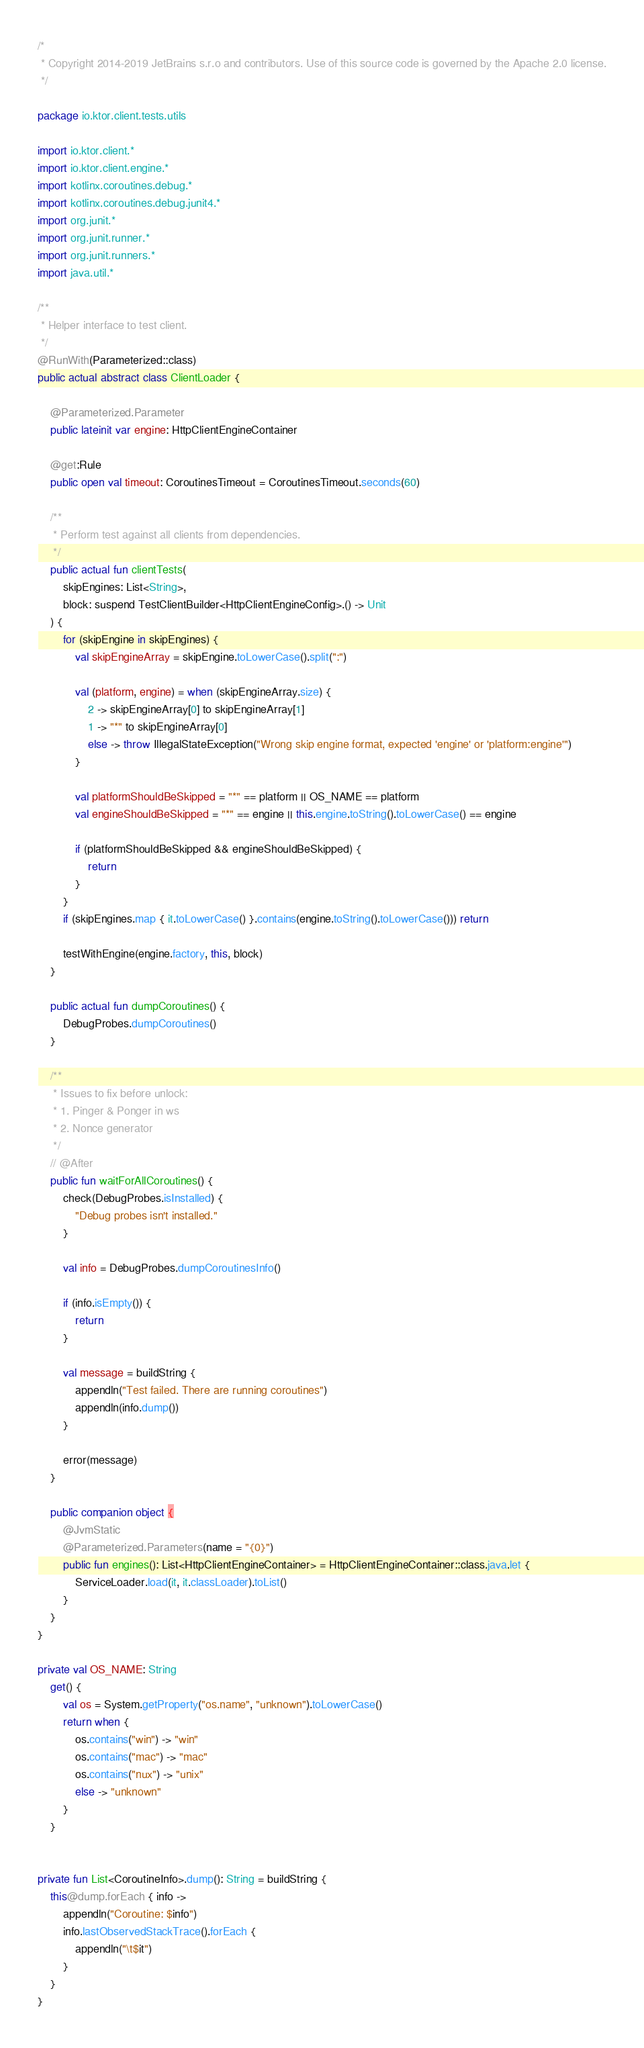Convert code to text. <code><loc_0><loc_0><loc_500><loc_500><_Kotlin_>/*
 * Copyright 2014-2019 JetBrains s.r.o and contributors. Use of this source code is governed by the Apache 2.0 license.
 */

package io.ktor.client.tests.utils

import io.ktor.client.*
import io.ktor.client.engine.*
import kotlinx.coroutines.debug.*
import kotlinx.coroutines.debug.junit4.*
import org.junit.*
import org.junit.runner.*
import org.junit.runners.*
import java.util.*

/**
 * Helper interface to test client.
 */
@RunWith(Parameterized::class)
public actual abstract class ClientLoader {

    @Parameterized.Parameter
    public lateinit var engine: HttpClientEngineContainer

    @get:Rule
    public open val timeout: CoroutinesTimeout = CoroutinesTimeout.seconds(60)

    /**
     * Perform test against all clients from dependencies.
     */
    public actual fun clientTests(
        skipEngines: List<String>,
        block: suspend TestClientBuilder<HttpClientEngineConfig>.() -> Unit
    ) {
        for (skipEngine in skipEngines) {
            val skipEngineArray = skipEngine.toLowerCase().split(":")

            val (platform, engine) = when (skipEngineArray.size) {
                2 -> skipEngineArray[0] to skipEngineArray[1]
                1 -> "*" to skipEngineArray[0]
                else -> throw IllegalStateException("Wrong skip engine format, expected 'engine' or 'platform:engine'")
            }

            val platformShouldBeSkipped = "*" == platform || OS_NAME == platform
            val engineShouldBeSkipped = "*" == engine || this.engine.toString().toLowerCase() == engine

            if (platformShouldBeSkipped && engineShouldBeSkipped) {
                return
            }
        }
        if (skipEngines.map { it.toLowerCase() }.contains(engine.toString().toLowerCase())) return

        testWithEngine(engine.factory, this, block)
    }

    public actual fun dumpCoroutines() {
        DebugProbes.dumpCoroutines()
    }

    /**
     * Issues to fix before unlock:
     * 1. Pinger & Ponger in ws
     * 2. Nonce generator
     */
    // @After
    public fun waitForAllCoroutines() {
        check(DebugProbes.isInstalled) {
            "Debug probes isn't installed."
        }

        val info = DebugProbes.dumpCoroutinesInfo()

        if (info.isEmpty()) {
            return
        }

        val message = buildString {
            appendln("Test failed. There are running coroutines")
            appendln(info.dump())
        }

        error(message)
    }

    public companion object {
        @JvmStatic
        @Parameterized.Parameters(name = "{0}")
        public fun engines(): List<HttpClientEngineContainer> = HttpClientEngineContainer::class.java.let {
            ServiceLoader.load(it, it.classLoader).toList()
        }
    }
}

private val OS_NAME: String
    get() {
        val os = System.getProperty("os.name", "unknown").toLowerCase()
        return when {
            os.contains("win") -> "win"
            os.contains("mac") -> "mac"
            os.contains("nux") -> "unix"
            else -> "unknown"
        }
    }


private fun List<CoroutineInfo>.dump(): String = buildString {
    this@dump.forEach { info ->
        appendln("Coroutine: $info")
        info.lastObservedStackTrace().forEach {
            appendln("\t$it")
        }
    }
}

</code> 